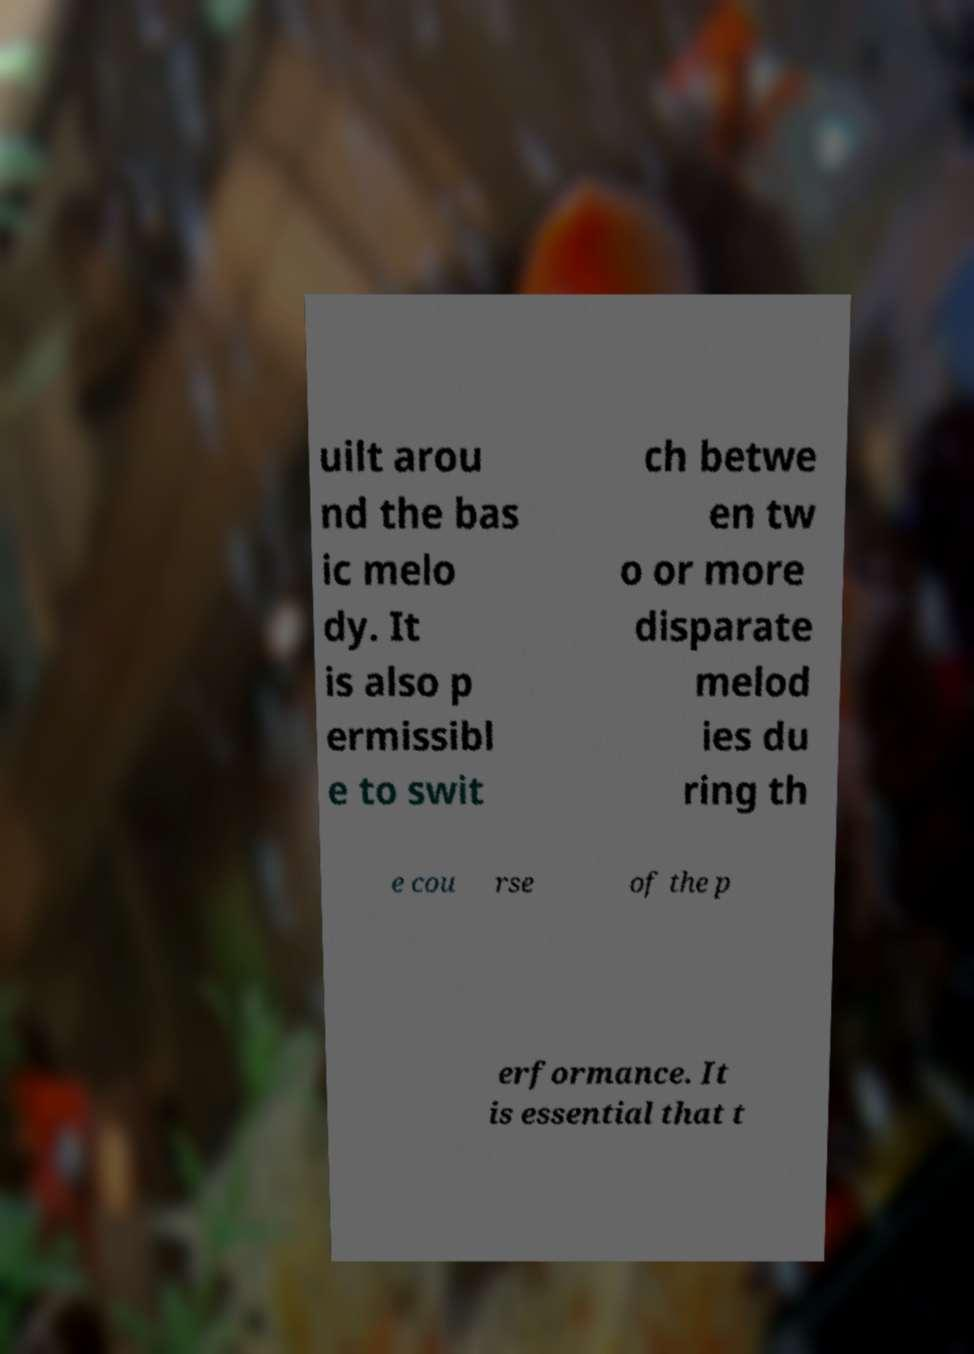Can you accurately transcribe the text from the provided image for me? uilt arou nd the bas ic melo dy. It is also p ermissibl e to swit ch betwe en tw o or more disparate melod ies du ring th e cou rse of the p erformance. It is essential that t 